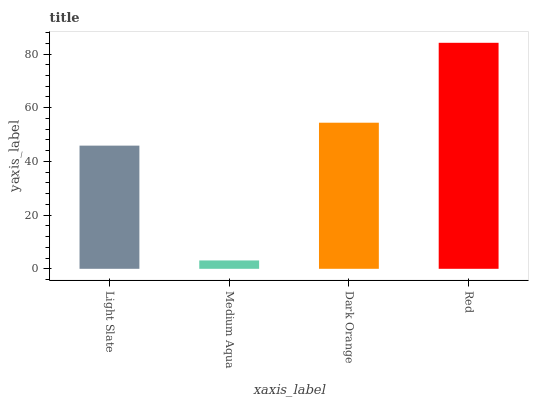Is Dark Orange the minimum?
Answer yes or no. No. Is Dark Orange the maximum?
Answer yes or no. No. Is Dark Orange greater than Medium Aqua?
Answer yes or no. Yes. Is Medium Aqua less than Dark Orange?
Answer yes or no. Yes. Is Medium Aqua greater than Dark Orange?
Answer yes or no. No. Is Dark Orange less than Medium Aqua?
Answer yes or no. No. Is Dark Orange the high median?
Answer yes or no. Yes. Is Light Slate the low median?
Answer yes or no. Yes. Is Red the high median?
Answer yes or no. No. Is Dark Orange the low median?
Answer yes or no. No. 